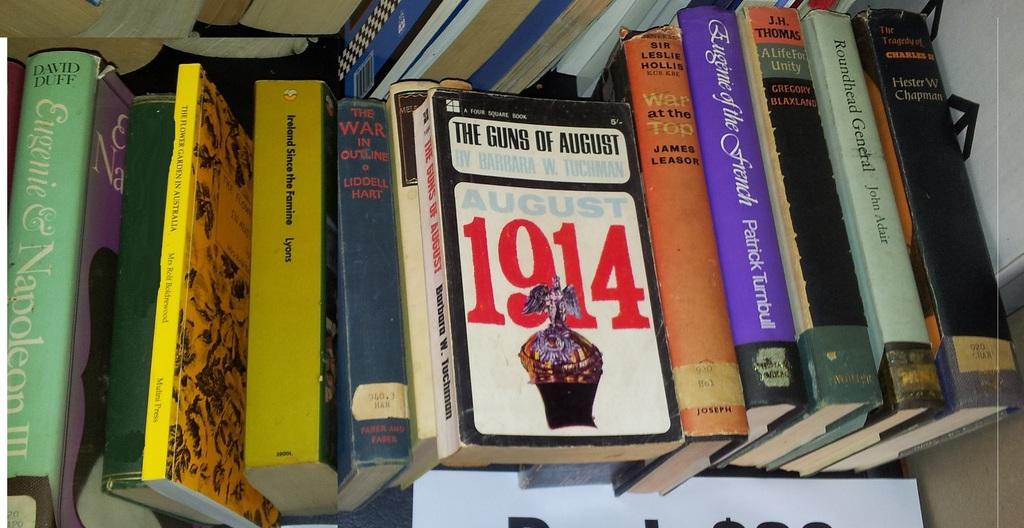Provide a one-sentence caption for the provided image. A row of books with the book 1914 on top. 